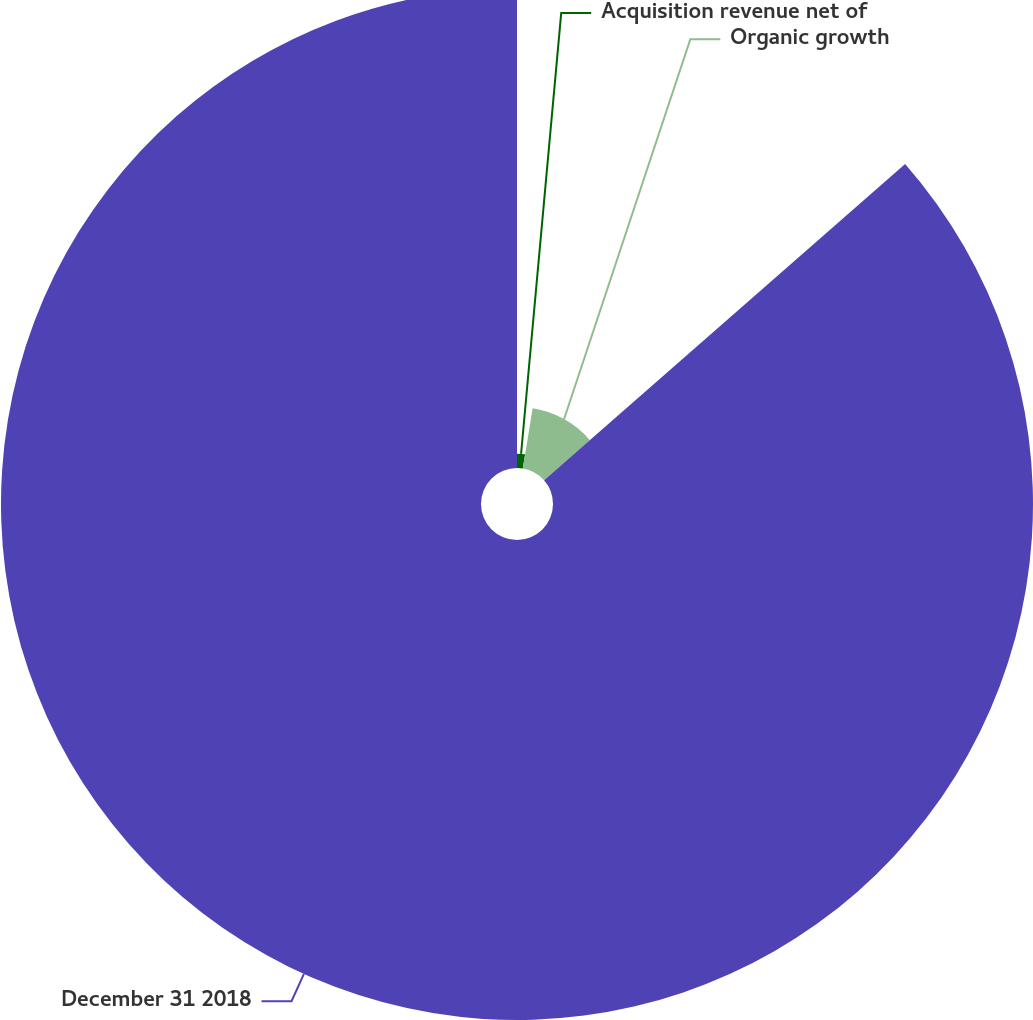<chart> <loc_0><loc_0><loc_500><loc_500><pie_chart><fcel>Acquisition revenue net of<fcel>Organic growth<fcel>December 31 2018<nl><fcel>2.58%<fcel>10.97%<fcel>86.45%<nl></chart> 